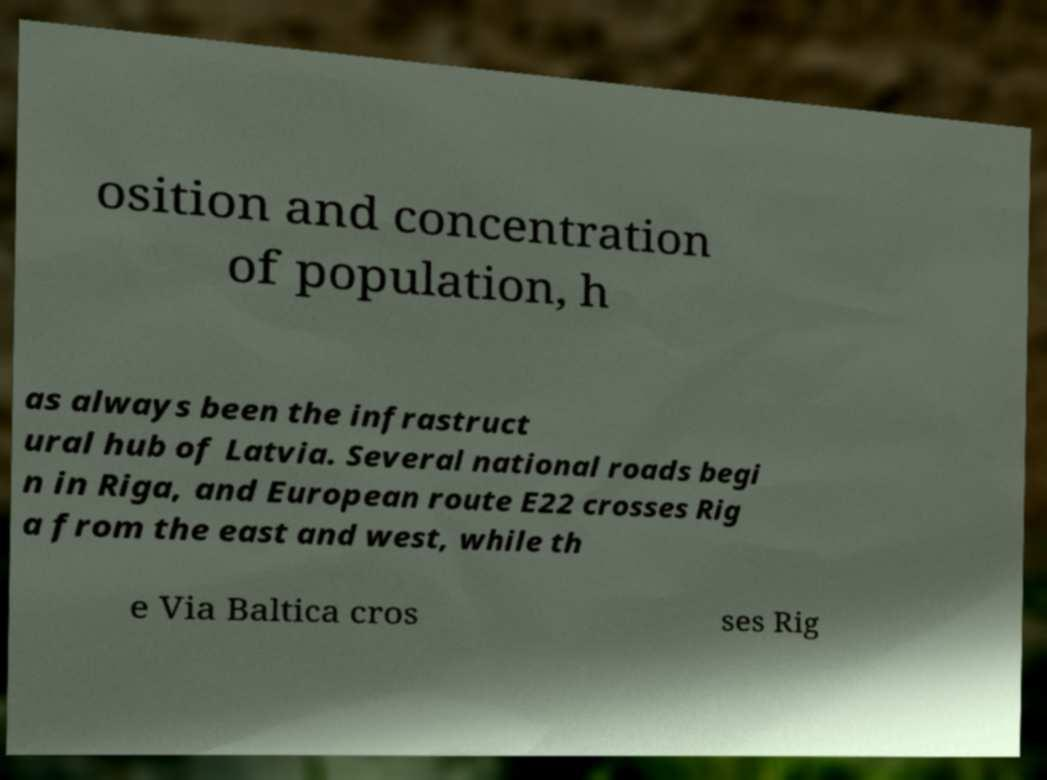Could you extract and type out the text from this image? osition and concentration of population, h as always been the infrastruct ural hub of Latvia. Several national roads begi n in Riga, and European route E22 crosses Rig a from the east and west, while th e Via Baltica cros ses Rig 